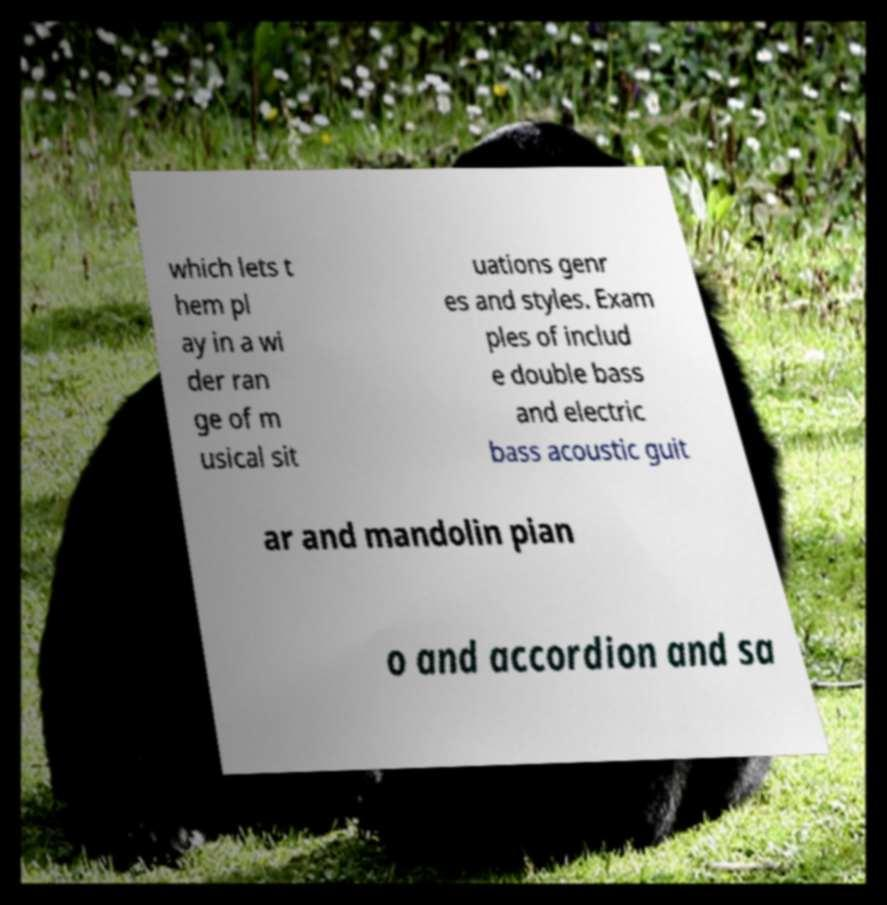Could you assist in decoding the text presented in this image and type it out clearly? which lets t hem pl ay in a wi der ran ge of m usical sit uations genr es and styles. Exam ples of includ e double bass and electric bass acoustic guit ar and mandolin pian o and accordion and sa 